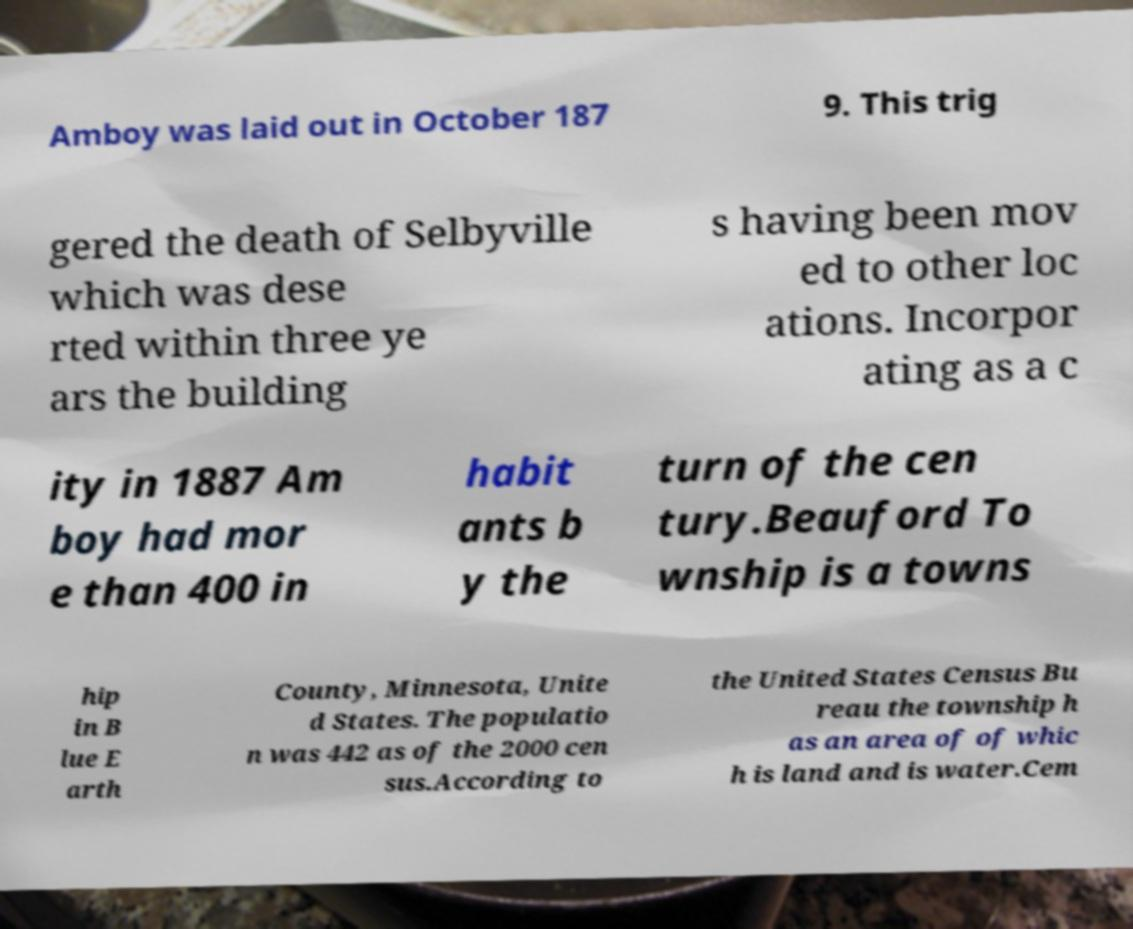Could you extract and type out the text from this image? Amboy was laid out in October 187 9. This trig gered the death of Selbyville which was dese rted within three ye ars the building s having been mov ed to other loc ations. Incorpor ating as a c ity in 1887 Am boy had mor e than 400 in habit ants b y the turn of the cen tury.Beauford To wnship is a towns hip in B lue E arth County, Minnesota, Unite d States. The populatio n was 442 as of the 2000 cen sus.According to the United States Census Bu reau the township h as an area of of whic h is land and is water.Cem 